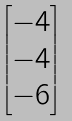Convert formula to latex. <formula><loc_0><loc_0><loc_500><loc_500>\begin{bmatrix} - 4 \\ - 4 \\ - 6 \end{bmatrix}</formula> 